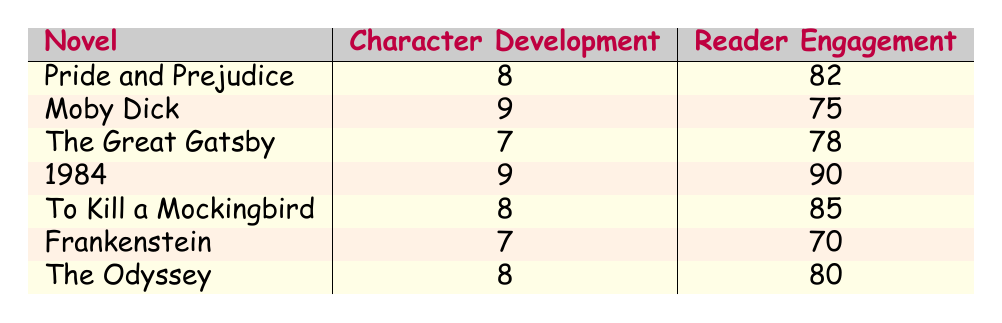What is the character development depth of "1984"? The table shows that "1984" has a character development depth rating of 9.
Answer: 9 Which novel has the highest reader engagement score? Upon examining the reader engagement scores, "1984" has the highest score at 90.
Answer: 90 What is the average character development depth among all the novels listed? To find the average, sum the character development depths (8 + 9 + 7 + 9 + 8 + 7 + 8 = 56) and divide by the total number of novels (7), which gives 56/7 = 8.
Answer: 8 Is the character development depth of "Frankenstein" greater than the character development depth of "The Great Gatsby"? "Frankenstein" has a depth of 7 and "The Great Gatsby" has a depth of 7 as well. Since both are equal, the answer is false.
Answer: No What is the difference in reader engagement score between "Moby Dick" and "The Odyssey"? The reader engagement score for "Moby Dick" is 75, and for "The Odyssey" it is 80. The difference is calculated as 80 - 75 = 5.
Answer: 5 Which two novels have the same character development depth of 8? Looking at the table, both "Pride and Prejudice" and "To Kill a Mockingbird" have a character development depth of 8.
Answer: Pride and Prejudice, To Kill a Mockingbird Is it true that "The Great Gatsby" has a higher character development depth than "Frankenstein"? "The Great Gatsby" has a depth of 7, while "Frankenstein" also has a depth of 7, so the answer is false.
Answer: No Which novel has the lowest reader engagement score, and what is that score? The table indicates that "Frankenstein" has the lowest reader engagement score of 70.
Answer: 70 What is the sum of the reader engagement scores for "Pride and Prejudice" and "To Kill a Mockingbird"? The scores for "Pride and Prejudice" is 82 and for "To Kill a Mockingbird" is 85, so their sum is 82 + 85 = 167.
Answer: 167 